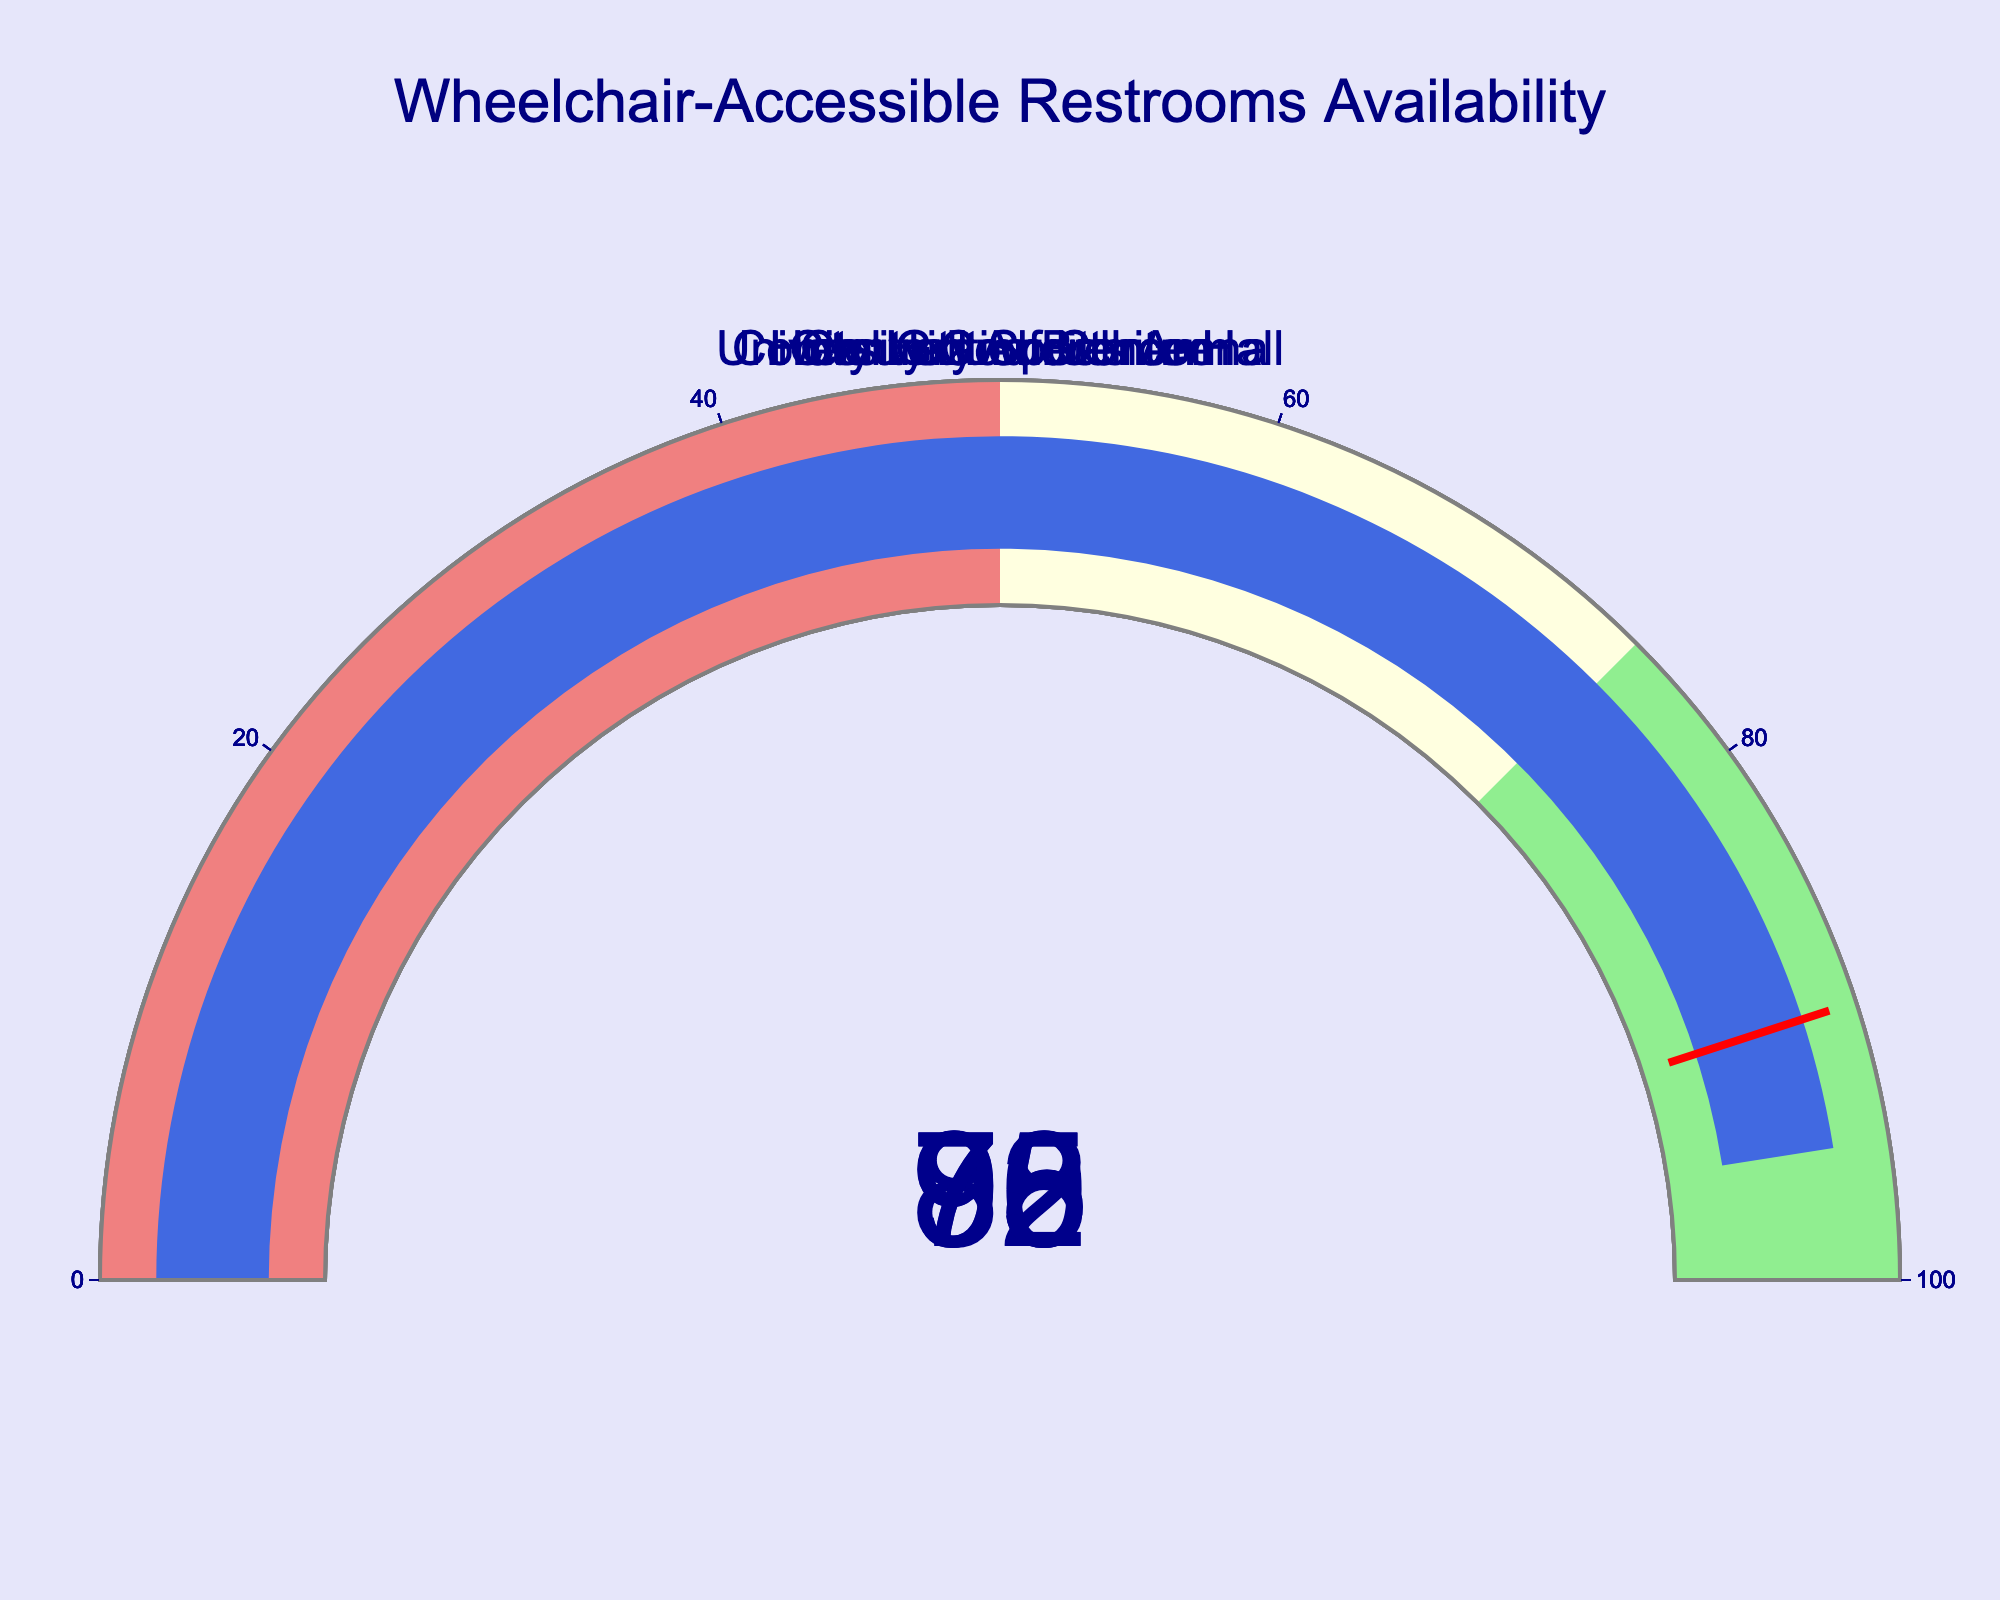what is the percentage availability of wheelchair-accessible restrooms at the Hotel Grand Ballroom? The gauge displays the percentage directly on the chart for each venue. For Hotel Grand Ballroom, the displayed value in the gauge is 92%.
Answer: 92% Which venue has the highest percentage of wheelchair-accessible restrooms? By visually inspecting the gauges, the University Conference Hall has the highest percentage at 95%.
Answer: University Conference Hall Compare the availability of wheelchair-accessible restrooms between the City Hall Auditorium and the Community Sports Arena. The City Hall Auditorium has a percentage of 78%, while the Community Sports Arena has 70%. The City Hall Auditorium has a higher percentage.
Answer: City Hall Auditorium What is the combined percentage of wheelchair-accessible restrooms availability for the Convention Center and Hotel Grand Ballroom? Adding the percentages of the Convention Center (85%) and Hotel Grand Ballroom (92%) gives a total of 177%.
Answer: 177% Which venues have a percentage above 90% for wheelchair-accessible restrooms availability? From the gauges, the venues with percentages above 90% are Hotel Grand Ballroom (92%) and University Conference Hall (95%).
Answer: Hotel Grand Ballroom, University Conference Hall What is the difference in percentage between the venue with the highest availability and the one with the lowest? The highest percentage is from University Conference Hall at 95%, and the lowest is from Community Sports Arena at 70%. The difference is 95% - 70% = 25%.
Answer: 25% What is the color of the gauge representing the Community Sports Arena, and what does it signify? The gauge for Community Sports Arena is in the light-yellow section, which represents a percentage between 50 and 75%.
Answer: Light yellow, 50-75% How many venues have above 75% wheelchair-accessible restrooms availability? The venues with above 75% availability are Convention Center (85%), Hotel Grand Ballroom (92%), City Hall Auditorium (78%), and University Conference Hall (95%). There are 4 venues.
Answer: 4 